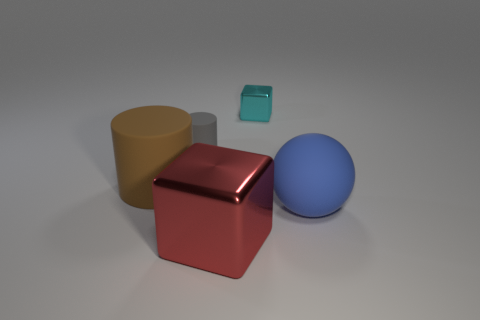Add 4 tiny cylinders. How many objects exist? 9 Subtract all cylinders. How many objects are left? 3 Add 4 blue matte objects. How many blue matte objects exist? 5 Subtract 1 red cubes. How many objects are left? 4 Subtract all small metallic things. Subtract all large rubber cubes. How many objects are left? 4 Add 4 small objects. How many small objects are left? 6 